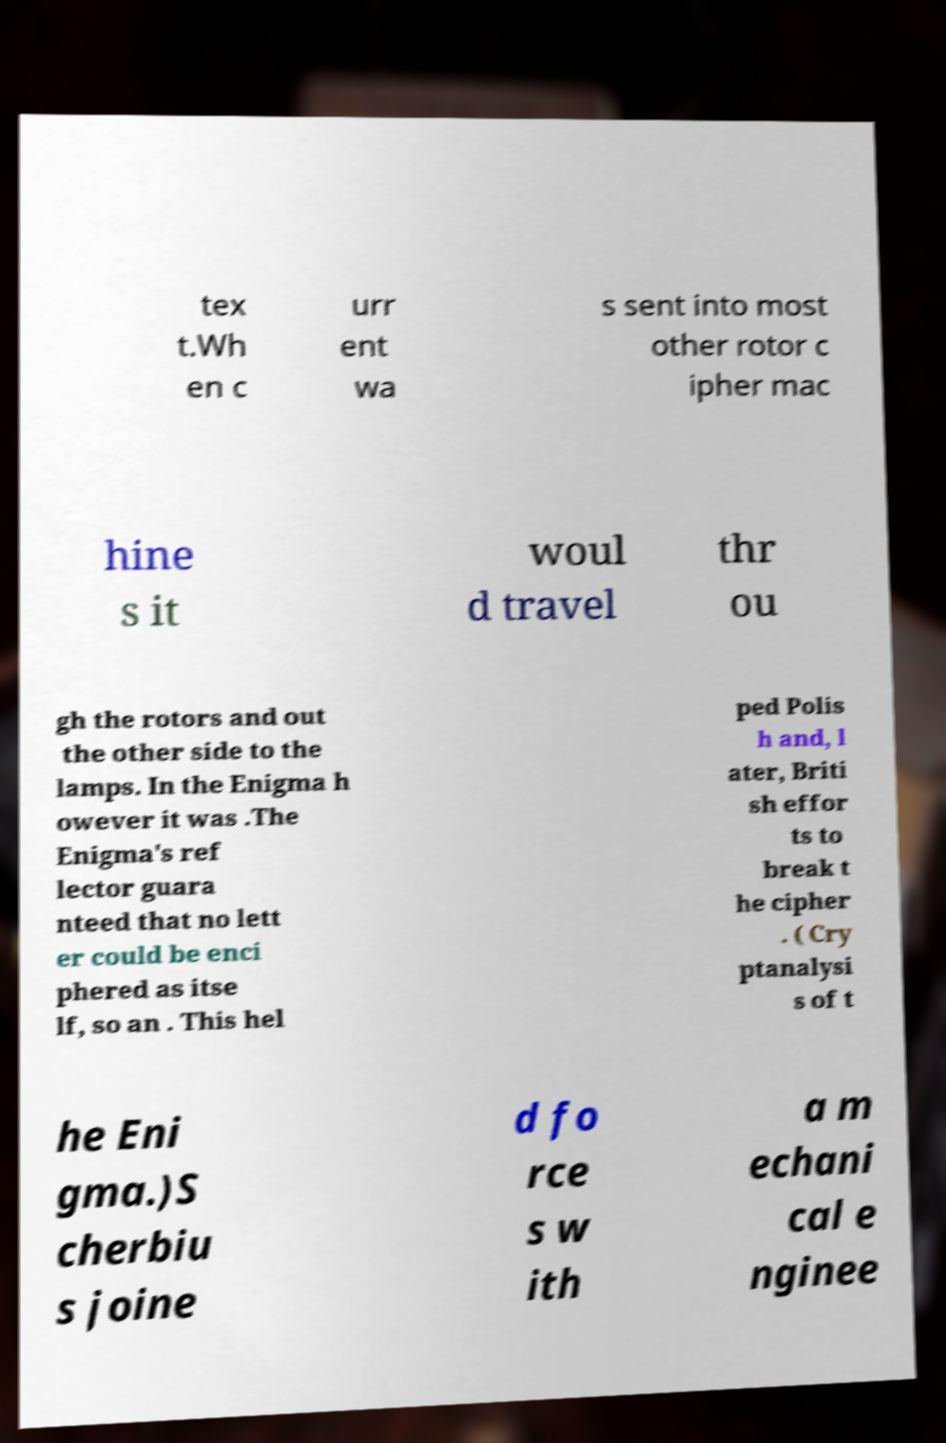Please identify and transcribe the text found in this image. tex t.Wh en c urr ent wa s sent into most other rotor c ipher mac hine s it woul d travel thr ou gh the rotors and out the other side to the lamps. In the Enigma h owever it was .The Enigma's ref lector guara nteed that no lett er could be enci phered as itse lf, so an . This hel ped Polis h and, l ater, Briti sh effor ts to break t he cipher . ( Cry ptanalysi s of t he Eni gma.)S cherbiu s joine d fo rce s w ith a m echani cal e nginee 